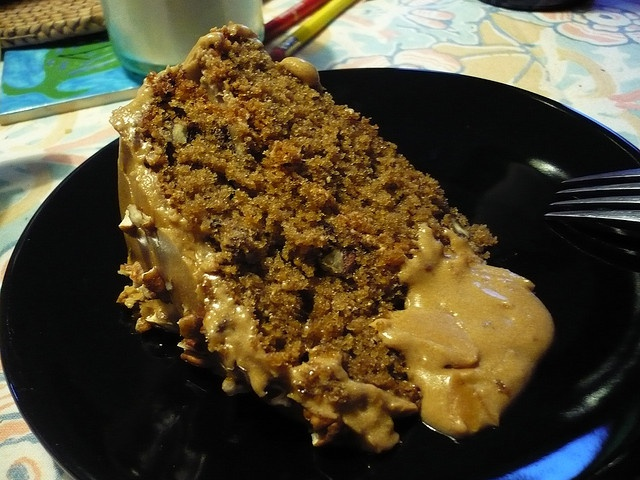Describe the objects in this image and their specific colors. I can see dining table in black, olive, maroon, and beige tones, cake in black, olive, and maroon tones, and fork in black, gray, and darkgray tones in this image. 